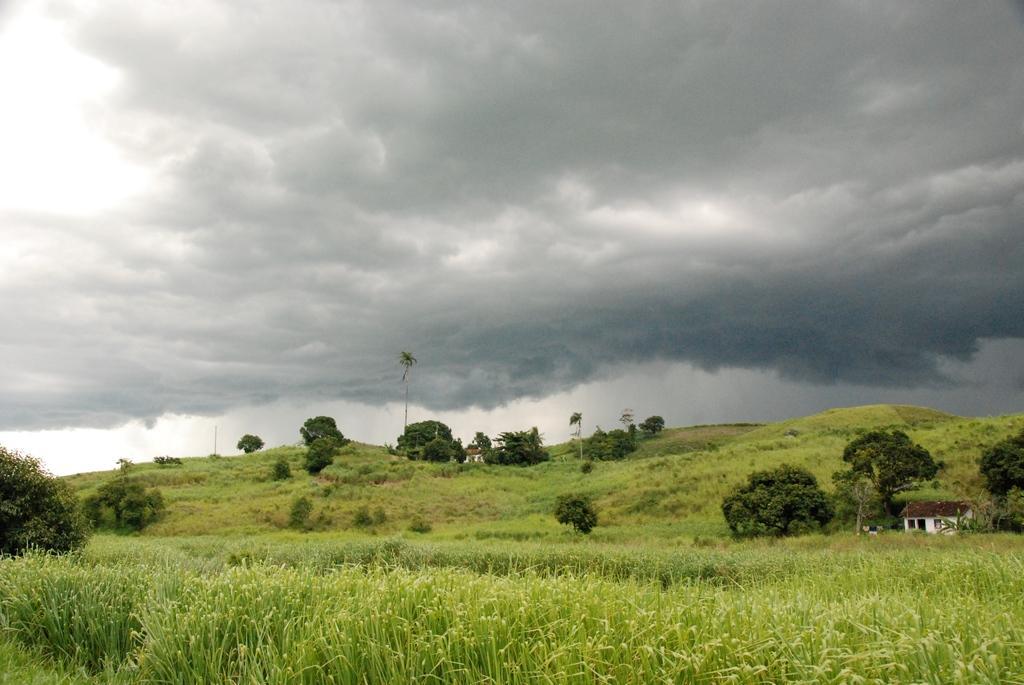How would you summarize this image in a sentence or two? In this image we can see trees, grass, houses, sky and clouds. 